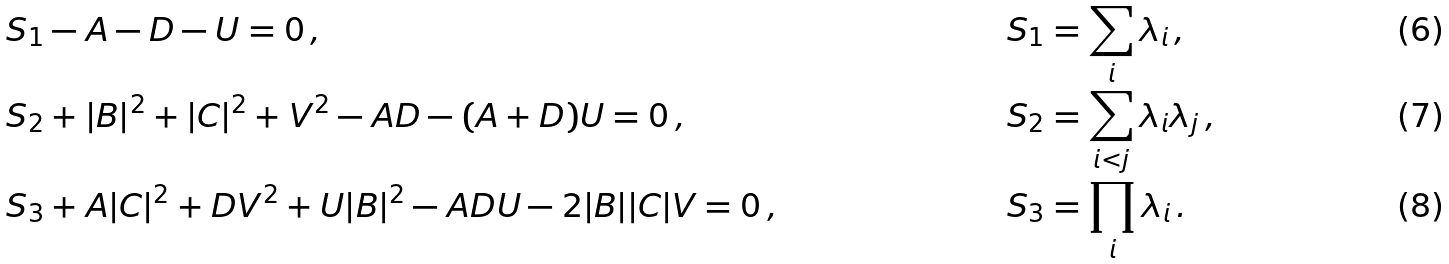Convert formula to latex. <formula><loc_0><loc_0><loc_500><loc_500>& S _ { 1 } - A - D - U = 0 \, , & S _ { 1 } & = \sum _ { i } \lambda _ { i } \, , \\ & S _ { 2 } + | B | ^ { 2 } + | C | ^ { 2 } + V ^ { 2 } - A D - ( A + D ) U = 0 \, , & S _ { 2 } & = \sum _ { i < j } \lambda _ { i } \lambda _ { j } \, , \\ & S _ { 3 } + A | C | ^ { 2 } + D V ^ { 2 } + U | B | ^ { 2 } - A D U - 2 | B | | C | V = 0 \, , & S _ { 3 } & = \prod _ { i } \lambda _ { i } \, .</formula> 